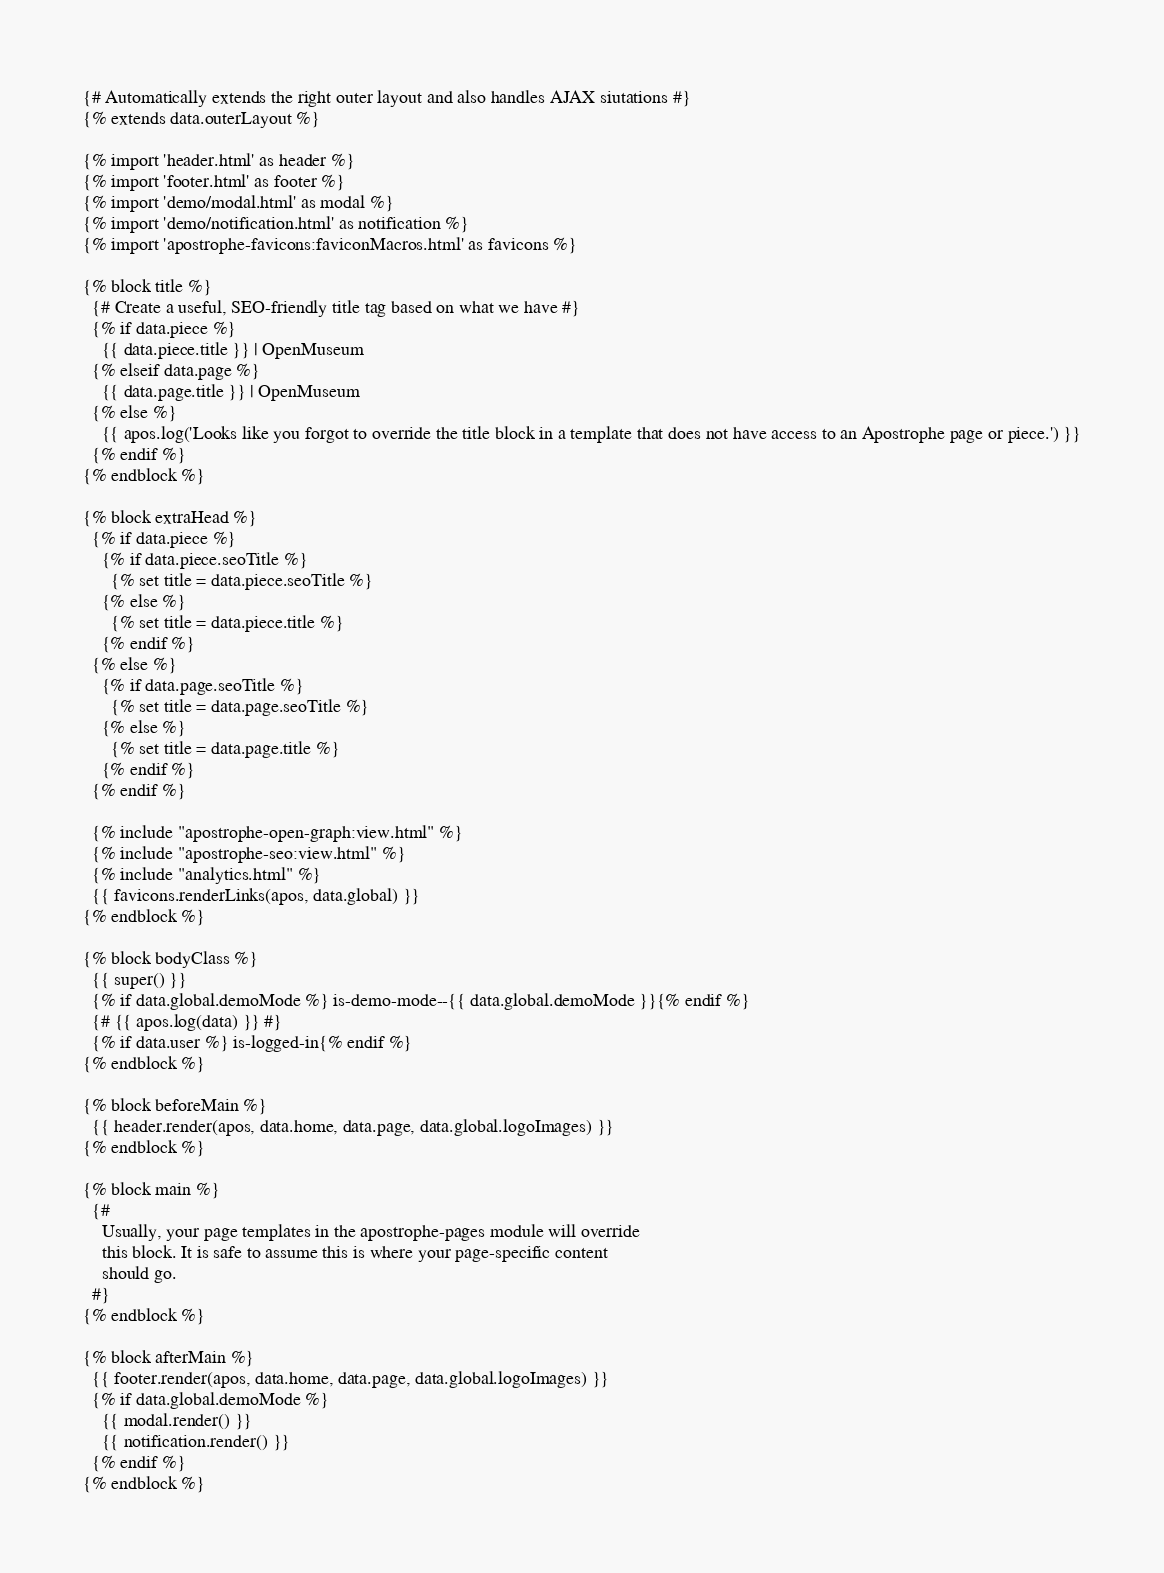<code> <loc_0><loc_0><loc_500><loc_500><_HTML_>{# Automatically extends the right outer layout and also handles AJAX siutations #}
{% extends data.outerLayout %}

{% import 'header.html' as header %}
{% import 'footer.html' as footer %}
{% import 'demo/modal.html' as modal %}
{% import 'demo/notification.html' as notification %}
{% import 'apostrophe-favicons:faviconMacros.html' as favicons %}

{% block title %}
  {# Create a useful, SEO-friendly title tag based on what we have #}
  {% if data.piece %}
    {{ data.piece.title }} | OpenMuseum
  {% elseif data.page %}
    {{ data.page.title }} | OpenMuseum
  {% else %}
    {{ apos.log('Looks like you forgot to override the title block in a template that does not have access to an Apostrophe page or piece.') }}
  {% endif %}
{% endblock %}

{% block extraHead %}
  {% if data.piece %}
    {% if data.piece.seoTitle %}
      {% set title = data.piece.seoTitle %}
    {% else %}
      {% set title = data.piece.title %}
    {% endif %}
  {% else %}
    {% if data.page.seoTitle %}
      {% set title = data.page.seoTitle %}
    {% else %}
      {% set title = data.page.title %}
    {% endif %}
  {% endif %}

  {% include "apostrophe-open-graph:view.html" %}
  {% include "apostrophe-seo:view.html" %}
  {% include "analytics.html" %}
  {{ favicons.renderLinks(apos, data.global) }}
{% endblock %}

{% block bodyClass %}
  {{ super() }}
  {% if data.global.demoMode %} is-demo-mode--{{ data.global.demoMode }}{% endif %}
  {# {{ apos.log(data) }} #}
  {% if data.user %} is-logged-in{% endif %}
{% endblock %}

{% block beforeMain %}
  {{ header.render(apos, data.home, data.page, data.global.logoImages) }}
{% endblock %}

{% block main %}
  {#
    Usually, your page templates in the apostrophe-pages module will override
    this block. It is safe to assume this is where your page-specific content
    should go.
  #}
{% endblock %}

{% block afterMain %}
  {{ footer.render(apos, data.home, data.page, data.global.logoImages) }}
  {% if data.global.demoMode %}
    {{ modal.render() }}
    {{ notification.render() }}
  {% endif %}
{% endblock %}
</code> 